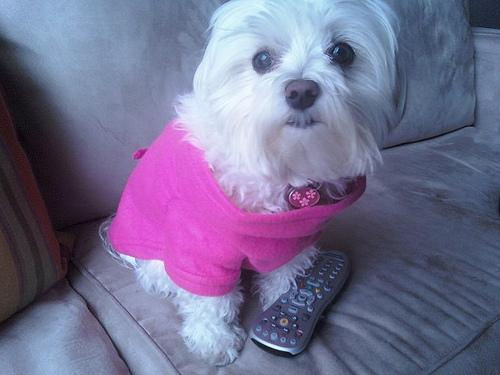What object is the item under the dog linked to?

Choices:
A) television
B) computer
C) boombox
D) radio television 